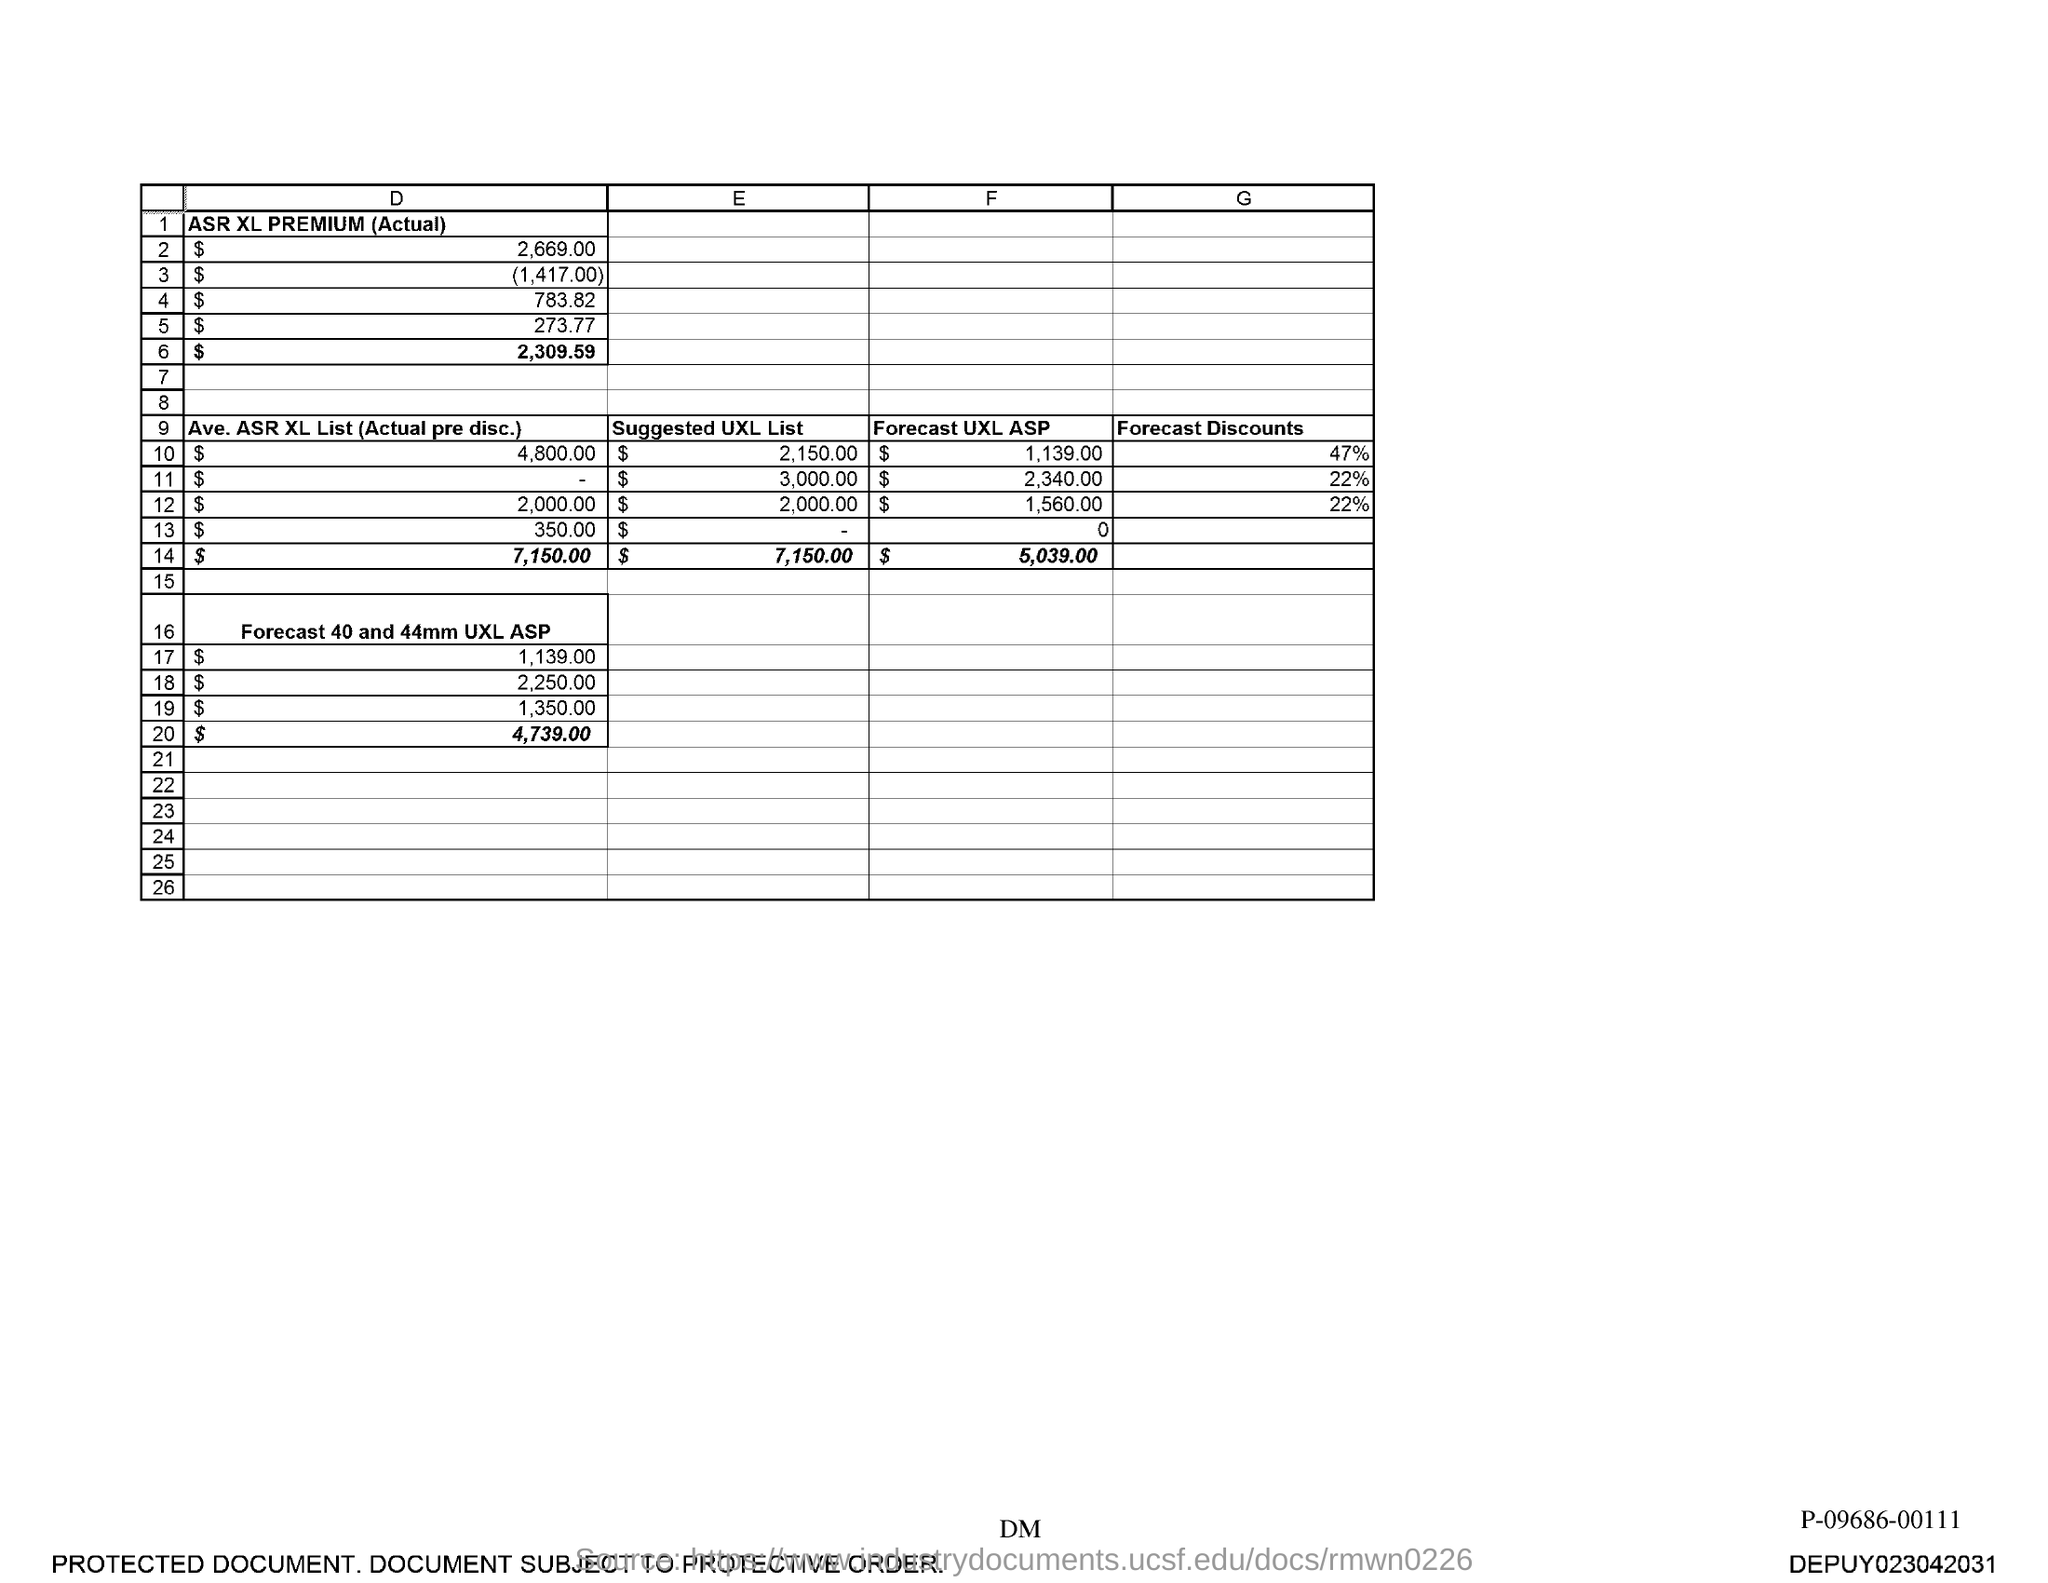Specify some key components in this picture. The total suggested UXL list is 7,150.00. 